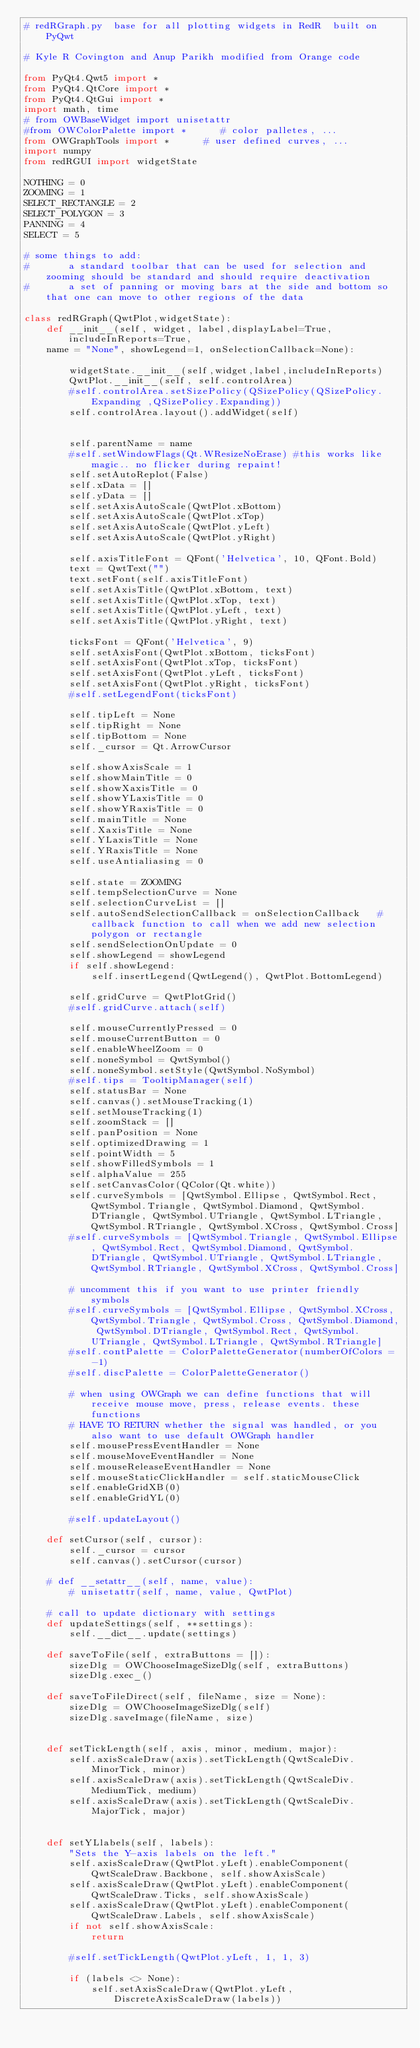Convert code to text. <code><loc_0><loc_0><loc_500><loc_500><_Python_># redRGraph.py  base for all plotting widgets in RedR  built on PyQwt

# Kyle R Covington and Anup Parikh modified from Orange code

from PyQt4.Qwt5 import *
from PyQt4.QtCore import *
from PyQt4.QtGui import *
import math, time
# from OWBaseWidget import unisetattr
#from OWColorPalette import *      # color palletes, ...
from OWGraphTools import *      # user defined curves, ...
import numpy
from redRGUI import widgetState

NOTHING = 0
ZOOMING = 1
SELECT_RECTANGLE = 2
SELECT_POLYGON = 3
PANNING = 4
SELECT = 5

# some things to add:  
#       a standard toolbar that can be used for selection and zooming should be standard and should require deactivation
#       a set of panning or moving bars at the side and bottom so that one can move to other regions of the data

class redRGraph(QwtPlot,widgetState):
    def __init__(self, widget, label,displayLabel=True,includeInReports=True,
    name = "None", showLegend=1, onSelectionCallback=None):
               
        widgetState.__init__(self,widget,label,includeInReports)
        QwtPlot.__init__(self, self.controlArea)
        #self.controlArea.setSizePolicy(QSizePolicy(QSizePolicy.Expanding ,QSizePolicy.Expanding))
        self.controlArea.layout().addWidget(self)
        
        
        self.parentName = name
        #self.setWindowFlags(Qt.WResizeNoErase) #this works like magic.. no flicker during repaint!
        self.setAutoReplot(False)
        self.xData = []
        self.yData = []
        self.setAxisAutoScale(QwtPlot.xBottom)
        self.setAxisAutoScale(QwtPlot.xTop)
        self.setAxisAutoScale(QwtPlot.yLeft)
        self.setAxisAutoScale(QwtPlot.yRight)

        self.axisTitleFont = QFont('Helvetica', 10, QFont.Bold)
        text = QwtText("")
        text.setFont(self.axisTitleFont)
        self.setAxisTitle(QwtPlot.xBottom, text)
        self.setAxisTitle(QwtPlot.xTop, text)
        self.setAxisTitle(QwtPlot.yLeft, text)
        self.setAxisTitle(QwtPlot.yRight, text)

        ticksFont = QFont('Helvetica', 9)
        self.setAxisFont(QwtPlot.xBottom, ticksFont)
        self.setAxisFont(QwtPlot.xTop, ticksFont)
        self.setAxisFont(QwtPlot.yLeft, ticksFont)
        self.setAxisFont(QwtPlot.yRight, ticksFont)
        #self.setLegendFont(ticksFont)

        self.tipLeft = None
        self.tipRight = None
        self.tipBottom = None
        self._cursor = Qt.ArrowCursor

        self.showAxisScale = 1
        self.showMainTitle = 0
        self.showXaxisTitle = 0
        self.showYLaxisTitle = 0
        self.showYRaxisTitle = 0
        self.mainTitle = None
        self.XaxisTitle = None
        self.YLaxisTitle = None
        self.YRaxisTitle = None
        self.useAntialiasing = 0

        self.state = ZOOMING
        self.tempSelectionCurve = None
        self.selectionCurveList = []
        self.autoSendSelectionCallback = onSelectionCallback   # callback function to call when we add new selection polygon or rectangle
        self.sendSelectionOnUpdate = 0
        self.showLegend = showLegend
        if self.showLegend:
            self.insertLegend(QwtLegend(), QwtPlot.BottomLegend)

        self.gridCurve = QwtPlotGrid()
        #self.gridCurve.attach(self)

        self.mouseCurrentlyPressed = 0
        self.mouseCurrentButton = 0
        self.enableWheelZoom = 0
        self.noneSymbol = QwtSymbol()
        self.noneSymbol.setStyle(QwtSymbol.NoSymbol)
        #self.tips = TooltipManager(self)
        self.statusBar = None
        self.canvas().setMouseTracking(1)
        self.setMouseTracking(1)
        self.zoomStack = []
        self.panPosition = None
        self.optimizedDrawing = 1
        self.pointWidth = 5
        self.showFilledSymbols = 1
        self.alphaValue = 255
        self.setCanvasColor(QColor(Qt.white))
        self.curveSymbols = [QwtSymbol.Ellipse, QwtSymbol.Rect, QwtSymbol.Triangle, QwtSymbol.Diamond, QwtSymbol.DTriangle, QwtSymbol.UTriangle, QwtSymbol.LTriangle, QwtSymbol.RTriangle, QwtSymbol.XCross, QwtSymbol.Cross]
        #self.curveSymbols = [QwtSymbol.Triangle, QwtSymbol.Ellipse, QwtSymbol.Rect, QwtSymbol.Diamond, QwtSymbol.DTriangle, QwtSymbol.UTriangle, QwtSymbol.LTriangle, QwtSymbol.RTriangle, QwtSymbol.XCross, QwtSymbol.Cross]

        # uncomment this if you want to use printer friendly symbols
        #self.curveSymbols = [QwtSymbol.Ellipse, QwtSymbol.XCross, QwtSymbol.Triangle, QwtSymbol.Cross, QwtSymbol.Diamond, QwtSymbol.DTriangle, QwtSymbol.Rect, QwtSymbol.UTriangle, QwtSymbol.LTriangle, QwtSymbol.RTriangle]
        #self.contPalette = ColorPaletteGenerator(numberOfColors = -1)
        #self.discPalette = ColorPaletteGenerator()

        # when using OWGraph we can define functions that will receive mouse move, press, release events. these functions
        # HAVE TO RETURN whether the signal was handled, or you also want to use default OWGraph handler
        self.mousePressEventHandler = None
        self.mouseMoveEventHandler = None
        self.mouseReleaseEventHandler = None
        self.mouseStaticClickHandler = self.staticMouseClick
        self.enableGridXB(0)
        self.enableGridYL(0)

        #self.updateLayout()
        
    def setCursor(self, cursor):
        self._cursor = cursor
        self.canvas().setCursor(cursor)

    # def __setattr__(self, name, value):
        # unisetattr(self, name, value, QwtPlot)

    # call to update dictionary with settings
    def updateSettings(self, **settings):
        self.__dict__.update(settings)

    def saveToFile(self, extraButtons = []):
        sizeDlg = OWChooseImageSizeDlg(self, extraButtons)
        sizeDlg.exec_()

    def saveToFileDirect(self, fileName, size = None):
        sizeDlg = OWChooseImageSizeDlg(self)
        sizeDlg.saveImage(fileName, size)


    def setTickLength(self, axis, minor, medium, major):
        self.axisScaleDraw(axis).setTickLength(QwtScaleDiv.MinorTick, minor)
        self.axisScaleDraw(axis).setTickLength(QwtScaleDiv.MediumTick, medium)
        self.axisScaleDraw(axis).setTickLength(QwtScaleDiv.MajorTick, major)


    def setYLlabels(self, labels):
        "Sets the Y-axis labels on the left."
        self.axisScaleDraw(QwtPlot.yLeft).enableComponent(QwtScaleDraw.Backbone, self.showAxisScale)
        self.axisScaleDraw(QwtPlot.yLeft).enableComponent(QwtScaleDraw.Ticks, self.showAxisScale)
        self.axisScaleDraw(QwtPlot.yLeft).enableComponent(QwtScaleDraw.Labels, self.showAxisScale)
        if not self.showAxisScale:
            return

        #self.setTickLength(QwtPlot.yLeft, 1, 1, 3)

        if (labels <> None):
            self.setAxisScaleDraw(QwtPlot.yLeft, DiscreteAxisScaleDraw(labels))</code> 